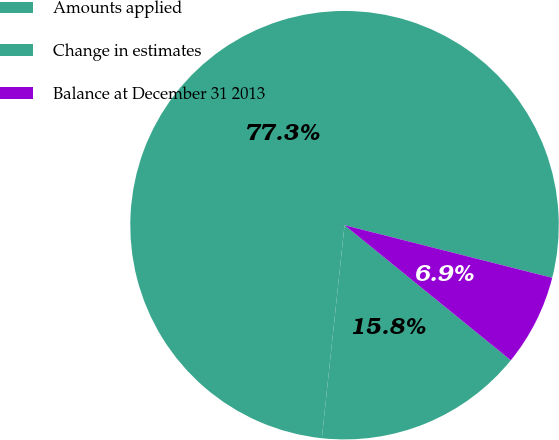<chart> <loc_0><loc_0><loc_500><loc_500><pie_chart><fcel>Amounts applied<fcel>Change in estimates<fcel>Balance at December 31 2013<nl><fcel>77.26%<fcel>15.83%<fcel>6.91%<nl></chart> 